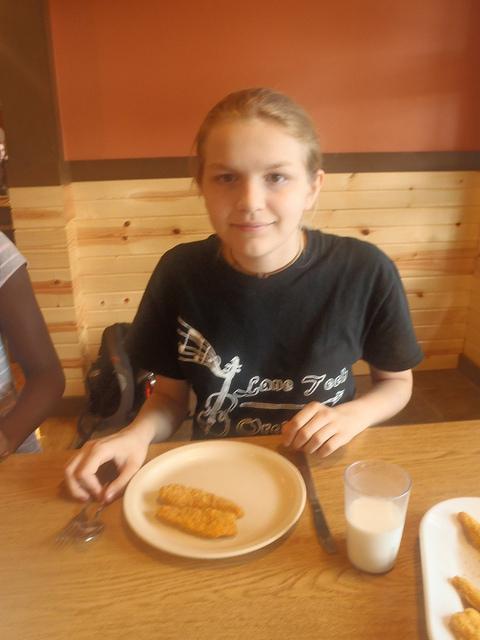What side dish would compliment his food quite well?
Answer the question by selecting the correct answer among the 4 following choices.
Options: Soup, apples, fries, milk. Fries. 